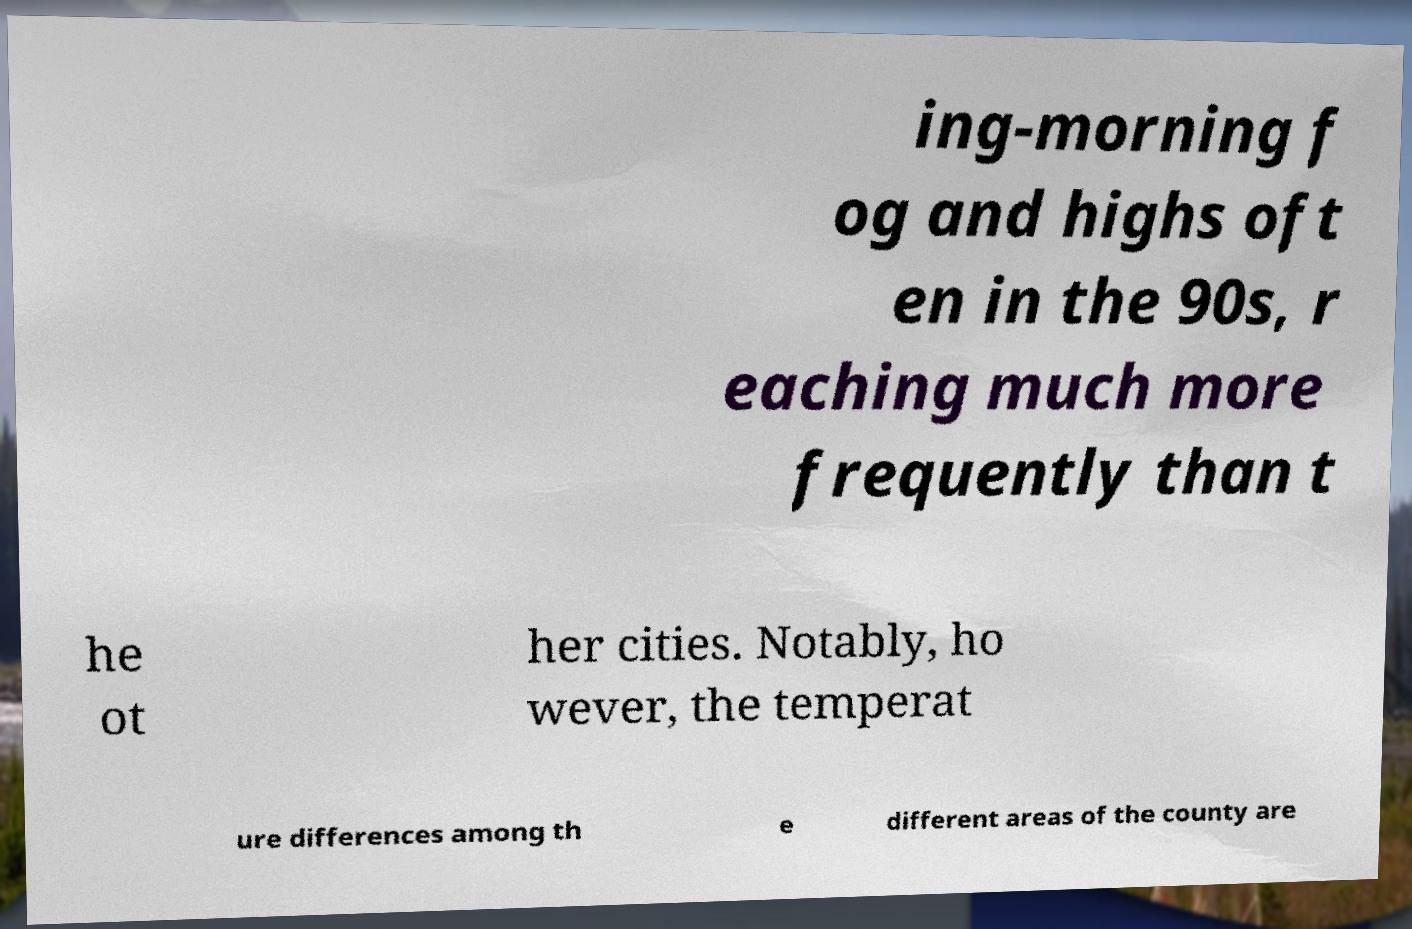Can you read and provide the text displayed in the image?This photo seems to have some interesting text. Can you extract and type it out for me? ing-morning f og and highs oft en in the 90s, r eaching much more frequently than t he ot her cities. Notably, ho wever, the temperat ure differences among th e different areas of the county are 